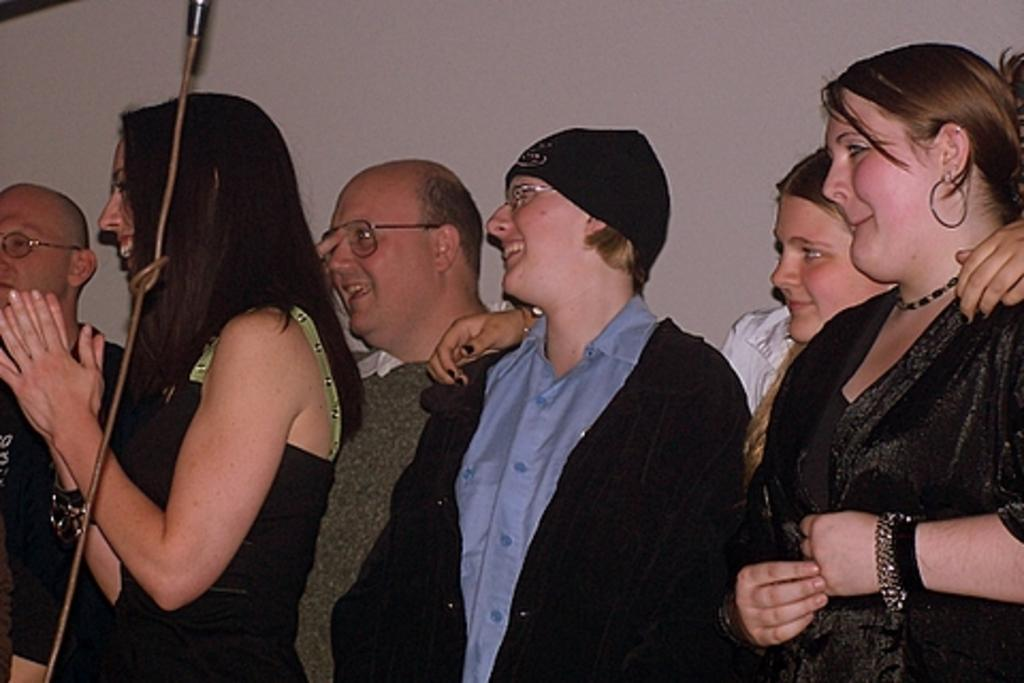How many people are in the image? There are multiple persons in the image. What are the persons doing in the image? The persons are standing. What is the facial expression of the persons in the image? The persons are smiling. Are any of the persons wearing any accessories in the image? Yes, some of the persons are wearing spectacles. What is the color of the background in the image? The background of the image is white. What type of carpentry tools can be seen in the image? There are no carpentry tools present in the image. What kind of plantation is visible in the background of the image? There is no plantation visible in the image; the background is white. 